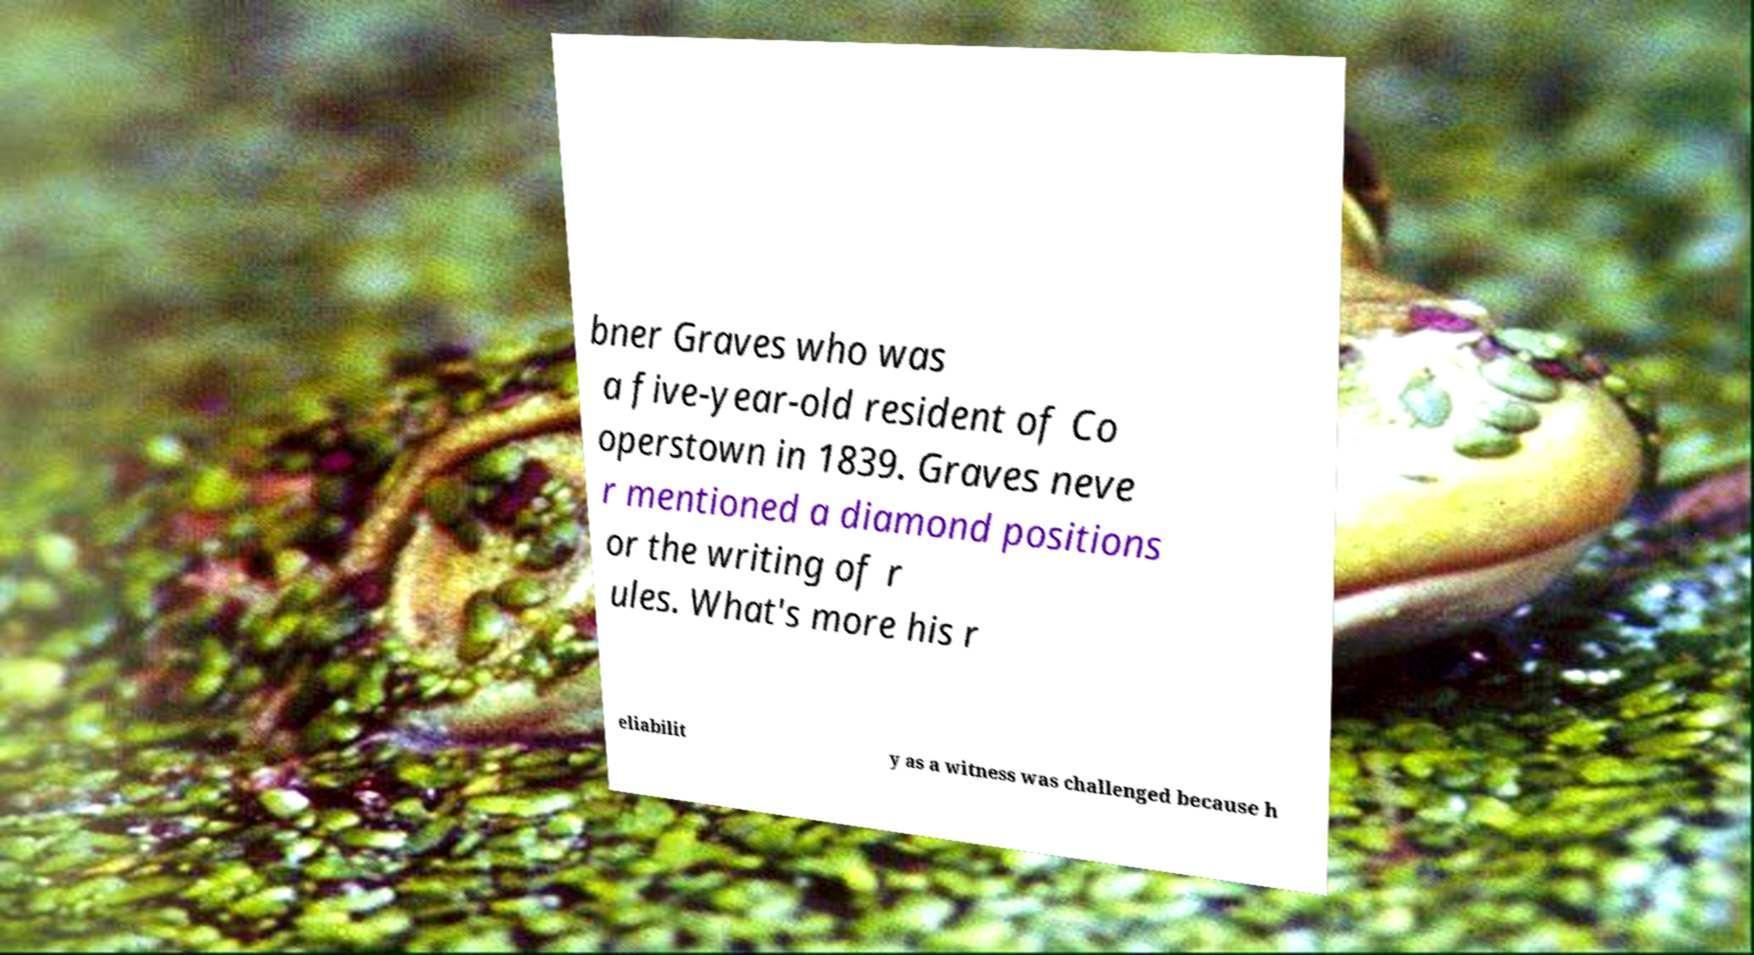For documentation purposes, I need the text within this image transcribed. Could you provide that? bner Graves who was a five-year-old resident of Co operstown in 1839. Graves neve r mentioned a diamond positions or the writing of r ules. What's more his r eliabilit y as a witness was challenged because h 